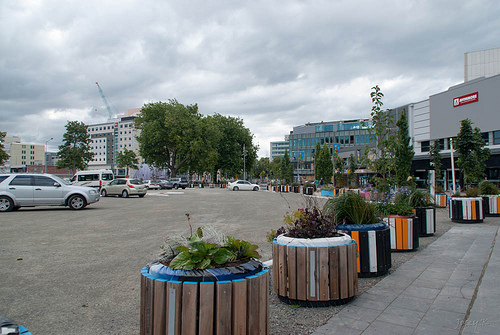<image>
Is there a car under the tree? No. The car is not positioned under the tree. The vertical relationship between these objects is different. Is there a car in front of the shop? No. The car is not in front of the shop. The spatial positioning shows a different relationship between these objects. 